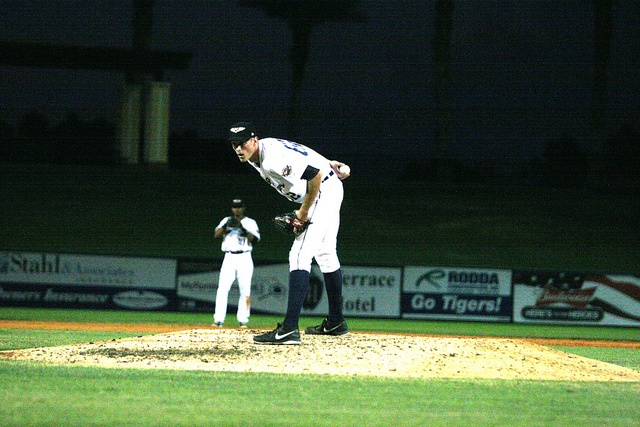Describe the objects in this image and their specific colors. I can see people in black, white, gray, and darkgray tones, people in black, white, gray, and lightblue tones, baseball glove in black, gray, and darkgreen tones, baseball glove in black, darkgreen, gray, and teal tones, and sports ball in black, white, darkgray, beige, and tan tones in this image. 